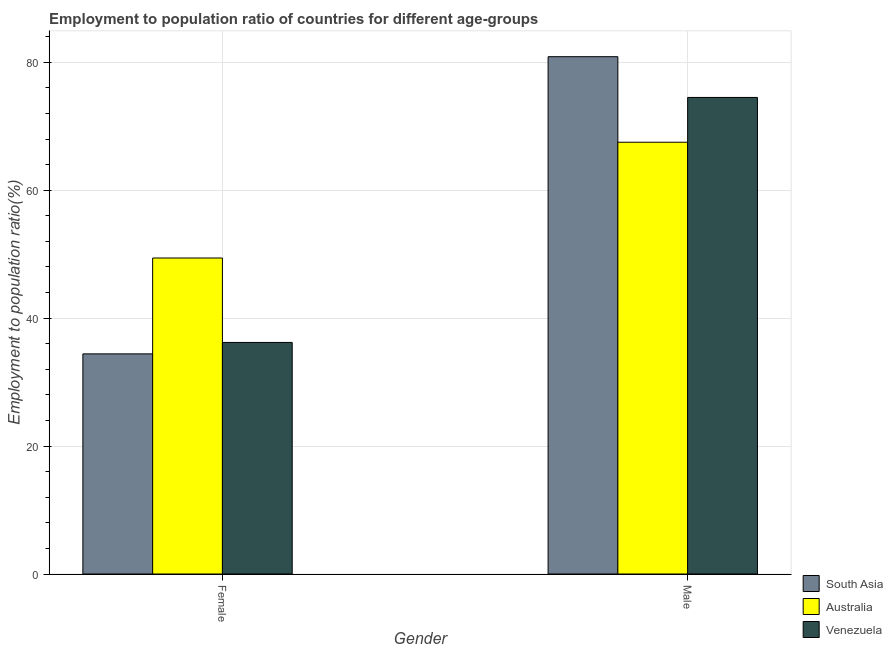Are the number of bars per tick equal to the number of legend labels?
Your answer should be very brief. Yes. Are the number of bars on each tick of the X-axis equal?
Make the answer very short. Yes. What is the employment to population ratio(female) in Venezuela?
Give a very brief answer. 36.2. Across all countries, what is the maximum employment to population ratio(male)?
Provide a short and direct response. 80.87. Across all countries, what is the minimum employment to population ratio(male)?
Your answer should be compact. 67.5. In which country was the employment to population ratio(female) minimum?
Give a very brief answer. South Asia. What is the total employment to population ratio(male) in the graph?
Your answer should be very brief. 222.87. What is the difference between the employment to population ratio(male) in Venezuela and the employment to population ratio(female) in Australia?
Give a very brief answer. 25.1. What is the average employment to population ratio(female) per country?
Provide a succinct answer. 40. What is the difference between the employment to population ratio(female) and employment to population ratio(male) in Australia?
Your response must be concise. -18.1. What is the ratio of the employment to population ratio(male) in Australia to that in South Asia?
Give a very brief answer. 0.83. What does the 1st bar from the left in Female represents?
Provide a succinct answer. South Asia. What does the 3rd bar from the right in Male represents?
Your answer should be compact. South Asia. How many bars are there?
Provide a short and direct response. 6. Are all the bars in the graph horizontal?
Offer a terse response. No. How many countries are there in the graph?
Provide a short and direct response. 3. What is the difference between two consecutive major ticks on the Y-axis?
Give a very brief answer. 20. Are the values on the major ticks of Y-axis written in scientific E-notation?
Ensure brevity in your answer.  No. Where does the legend appear in the graph?
Provide a short and direct response. Bottom right. How many legend labels are there?
Offer a very short reply. 3. What is the title of the graph?
Your response must be concise. Employment to population ratio of countries for different age-groups. Does "Zimbabwe" appear as one of the legend labels in the graph?
Give a very brief answer. No. What is the label or title of the X-axis?
Your response must be concise. Gender. What is the Employment to population ratio(%) of South Asia in Female?
Keep it short and to the point. 34.41. What is the Employment to population ratio(%) of Australia in Female?
Make the answer very short. 49.4. What is the Employment to population ratio(%) of Venezuela in Female?
Provide a succinct answer. 36.2. What is the Employment to population ratio(%) in South Asia in Male?
Make the answer very short. 80.87. What is the Employment to population ratio(%) in Australia in Male?
Provide a succinct answer. 67.5. What is the Employment to population ratio(%) of Venezuela in Male?
Your answer should be very brief. 74.5. Across all Gender, what is the maximum Employment to population ratio(%) in South Asia?
Your response must be concise. 80.87. Across all Gender, what is the maximum Employment to population ratio(%) in Australia?
Offer a very short reply. 67.5. Across all Gender, what is the maximum Employment to population ratio(%) of Venezuela?
Provide a succinct answer. 74.5. Across all Gender, what is the minimum Employment to population ratio(%) in South Asia?
Your answer should be compact. 34.41. Across all Gender, what is the minimum Employment to population ratio(%) in Australia?
Keep it short and to the point. 49.4. Across all Gender, what is the minimum Employment to population ratio(%) in Venezuela?
Your response must be concise. 36.2. What is the total Employment to population ratio(%) in South Asia in the graph?
Offer a very short reply. 115.28. What is the total Employment to population ratio(%) of Australia in the graph?
Provide a short and direct response. 116.9. What is the total Employment to population ratio(%) of Venezuela in the graph?
Provide a short and direct response. 110.7. What is the difference between the Employment to population ratio(%) in South Asia in Female and that in Male?
Your response must be concise. -46.46. What is the difference between the Employment to population ratio(%) of Australia in Female and that in Male?
Your answer should be very brief. -18.1. What is the difference between the Employment to population ratio(%) of Venezuela in Female and that in Male?
Offer a terse response. -38.3. What is the difference between the Employment to population ratio(%) in South Asia in Female and the Employment to population ratio(%) in Australia in Male?
Offer a terse response. -33.09. What is the difference between the Employment to population ratio(%) of South Asia in Female and the Employment to population ratio(%) of Venezuela in Male?
Offer a very short reply. -40.09. What is the difference between the Employment to population ratio(%) in Australia in Female and the Employment to population ratio(%) in Venezuela in Male?
Your answer should be very brief. -25.1. What is the average Employment to population ratio(%) in South Asia per Gender?
Your answer should be very brief. 57.64. What is the average Employment to population ratio(%) in Australia per Gender?
Provide a short and direct response. 58.45. What is the average Employment to population ratio(%) of Venezuela per Gender?
Your answer should be compact. 55.35. What is the difference between the Employment to population ratio(%) in South Asia and Employment to population ratio(%) in Australia in Female?
Your answer should be very brief. -14.99. What is the difference between the Employment to population ratio(%) of South Asia and Employment to population ratio(%) of Venezuela in Female?
Your answer should be compact. -1.79. What is the difference between the Employment to population ratio(%) in Australia and Employment to population ratio(%) in Venezuela in Female?
Your answer should be compact. 13.2. What is the difference between the Employment to population ratio(%) in South Asia and Employment to population ratio(%) in Australia in Male?
Offer a very short reply. 13.37. What is the difference between the Employment to population ratio(%) of South Asia and Employment to population ratio(%) of Venezuela in Male?
Offer a very short reply. 6.37. What is the difference between the Employment to population ratio(%) in Australia and Employment to population ratio(%) in Venezuela in Male?
Keep it short and to the point. -7. What is the ratio of the Employment to population ratio(%) in South Asia in Female to that in Male?
Your answer should be very brief. 0.43. What is the ratio of the Employment to population ratio(%) in Australia in Female to that in Male?
Provide a short and direct response. 0.73. What is the ratio of the Employment to population ratio(%) in Venezuela in Female to that in Male?
Keep it short and to the point. 0.49. What is the difference between the highest and the second highest Employment to population ratio(%) in South Asia?
Your response must be concise. 46.46. What is the difference between the highest and the second highest Employment to population ratio(%) of Australia?
Provide a succinct answer. 18.1. What is the difference between the highest and the second highest Employment to population ratio(%) of Venezuela?
Make the answer very short. 38.3. What is the difference between the highest and the lowest Employment to population ratio(%) of South Asia?
Make the answer very short. 46.46. What is the difference between the highest and the lowest Employment to population ratio(%) in Australia?
Give a very brief answer. 18.1. What is the difference between the highest and the lowest Employment to population ratio(%) in Venezuela?
Keep it short and to the point. 38.3. 